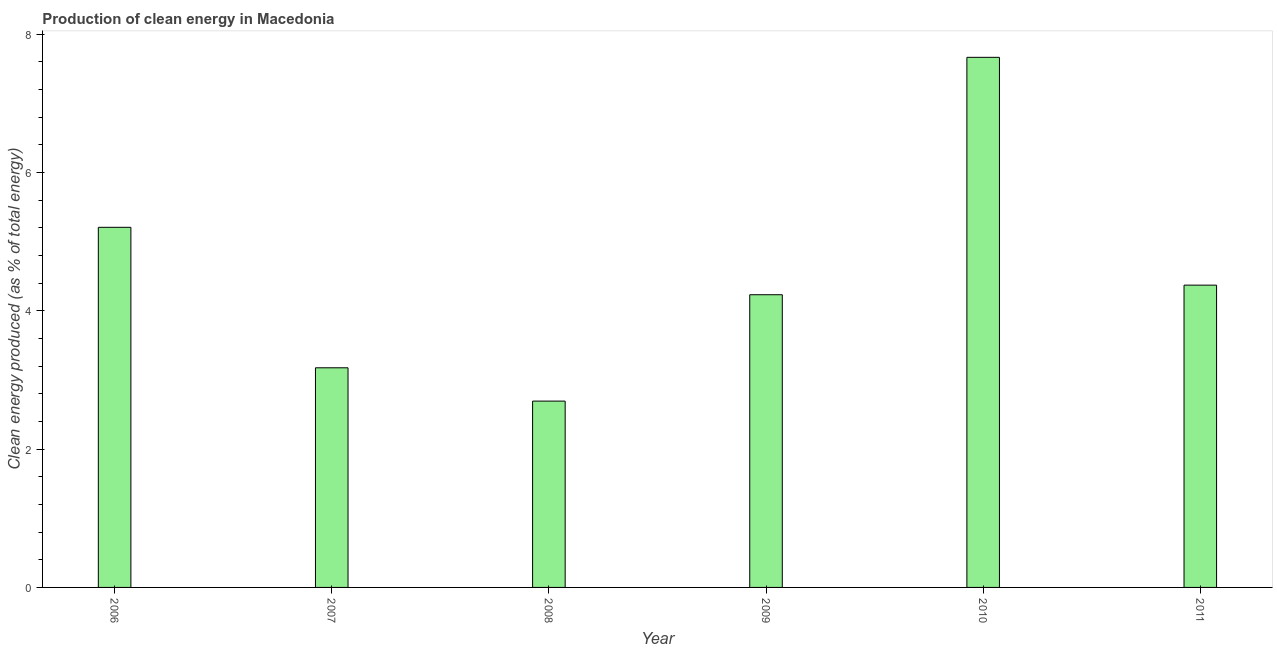Does the graph contain any zero values?
Your answer should be very brief. No. What is the title of the graph?
Your response must be concise. Production of clean energy in Macedonia. What is the label or title of the Y-axis?
Provide a succinct answer. Clean energy produced (as % of total energy). What is the production of clean energy in 2010?
Offer a very short reply. 7.67. Across all years, what is the maximum production of clean energy?
Offer a very short reply. 7.67. Across all years, what is the minimum production of clean energy?
Offer a very short reply. 2.69. In which year was the production of clean energy maximum?
Provide a short and direct response. 2010. What is the sum of the production of clean energy?
Keep it short and to the point. 27.35. What is the difference between the production of clean energy in 2010 and 2011?
Give a very brief answer. 3.29. What is the average production of clean energy per year?
Keep it short and to the point. 4.56. What is the median production of clean energy?
Provide a succinct answer. 4.3. In how many years, is the production of clean energy greater than 2.8 %?
Your response must be concise. 5. What is the ratio of the production of clean energy in 2006 to that in 2009?
Offer a terse response. 1.23. Is the production of clean energy in 2006 less than that in 2010?
Your answer should be very brief. Yes. What is the difference between the highest and the second highest production of clean energy?
Offer a very short reply. 2.46. What is the difference between the highest and the lowest production of clean energy?
Keep it short and to the point. 4.97. In how many years, is the production of clean energy greater than the average production of clean energy taken over all years?
Keep it short and to the point. 2. Are all the bars in the graph horizontal?
Give a very brief answer. No. Are the values on the major ticks of Y-axis written in scientific E-notation?
Provide a succinct answer. No. What is the Clean energy produced (as % of total energy) in 2006?
Your answer should be compact. 5.21. What is the Clean energy produced (as % of total energy) in 2007?
Keep it short and to the point. 3.18. What is the Clean energy produced (as % of total energy) in 2008?
Give a very brief answer. 2.69. What is the Clean energy produced (as % of total energy) in 2009?
Offer a very short reply. 4.23. What is the Clean energy produced (as % of total energy) in 2010?
Provide a succinct answer. 7.67. What is the Clean energy produced (as % of total energy) in 2011?
Offer a very short reply. 4.37. What is the difference between the Clean energy produced (as % of total energy) in 2006 and 2007?
Your response must be concise. 2.03. What is the difference between the Clean energy produced (as % of total energy) in 2006 and 2008?
Keep it short and to the point. 2.51. What is the difference between the Clean energy produced (as % of total energy) in 2006 and 2009?
Offer a terse response. 0.97. What is the difference between the Clean energy produced (as % of total energy) in 2006 and 2010?
Give a very brief answer. -2.46. What is the difference between the Clean energy produced (as % of total energy) in 2006 and 2011?
Your response must be concise. 0.84. What is the difference between the Clean energy produced (as % of total energy) in 2007 and 2008?
Provide a succinct answer. 0.48. What is the difference between the Clean energy produced (as % of total energy) in 2007 and 2009?
Give a very brief answer. -1.06. What is the difference between the Clean energy produced (as % of total energy) in 2007 and 2010?
Your response must be concise. -4.49. What is the difference between the Clean energy produced (as % of total energy) in 2007 and 2011?
Provide a succinct answer. -1.2. What is the difference between the Clean energy produced (as % of total energy) in 2008 and 2009?
Offer a very short reply. -1.54. What is the difference between the Clean energy produced (as % of total energy) in 2008 and 2010?
Provide a succinct answer. -4.97. What is the difference between the Clean energy produced (as % of total energy) in 2008 and 2011?
Your response must be concise. -1.68. What is the difference between the Clean energy produced (as % of total energy) in 2009 and 2010?
Provide a short and direct response. -3.43. What is the difference between the Clean energy produced (as % of total energy) in 2009 and 2011?
Offer a very short reply. -0.14. What is the difference between the Clean energy produced (as % of total energy) in 2010 and 2011?
Your response must be concise. 3.29. What is the ratio of the Clean energy produced (as % of total energy) in 2006 to that in 2007?
Ensure brevity in your answer.  1.64. What is the ratio of the Clean energy produced (as % of total energy) in 2006 to that in 2008?
Your answer should be very brief. 1.93. What is the ratio of the Clean energy produced (as % of total energy) in 2006 to that in 2009?
Offer a terse response. 1.23. What is the ratio of the Clean energy produced (as % of total energy) in 2006 to that in 2010?
Your response must be concise. 0.68. What is the ratio of the Clean energy produced (as % of total energy) in 2006 to that in 2011?
Your answer should be very brief. 1.19. What is the ratio of the Clean energy produced (as % of total energy) in 2007 to that in 2008?
Your response must be concise. 1.18. What is the ratio of the Clean energy produced (as % of total energy) in 2007 to that in 2010?
Keep it short and to the point. 0.41. What is the ratio of the Clean energy produced (as % of total energy) in 2007 to that in 2011?
Offer a terse response. 0.73. What is the ratio of the Clean energy produced (as % of total energy) in 2008 to that in 2009?
Your answer should be very brief. 0.64. What is the ratio of the Clean energy produced (as % of total energy) in 2008 to that in 2010?
Offer a very short reply. 0.35. What is the ratio of the Clean energy produced (as % of total energy) in 2008 to that in 2011?
Your answer should be very brief. 0.62. What is the ratio of the Clean energy produced (as % of total energy) in 2009 to that in 2010?
Your response must be concise. 0.55. What is the ratio of the Clean energy produced (as % of total energy) in 2009 to that in 2011?
Provide a succinct answer. 0.97. What is the ratio of the Clean energy produced (as % of total energy) in 2010 to that in 2011?
Your answer should be very brief. 1.75. 